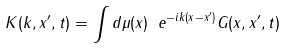<formula> <loc_0><loc_0><loc_500><loc_500>K ( k , x ^ { \prime } , t ) = \int d \mu ( x ) \ e ^ { - i k ( x - x ^ { \prime } ) } G ( x , x ^ { \prime } , t )</formula> 